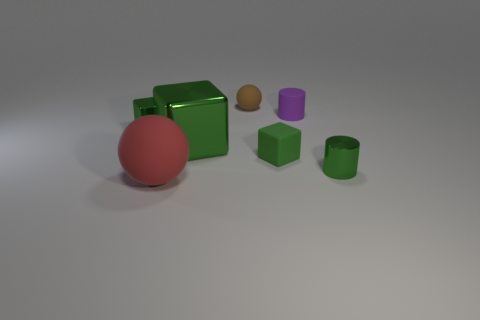What can you infer about the lighting in the scene? The lighting in the scene suggests a soft overhead source, resulting in gentle shadows cast directly beneath the objects. The lack of multiple strong shadows or harsh highlights indicates that diffused or ambient lighting is being used, which creates a soft and even illumination throughout the scene. 